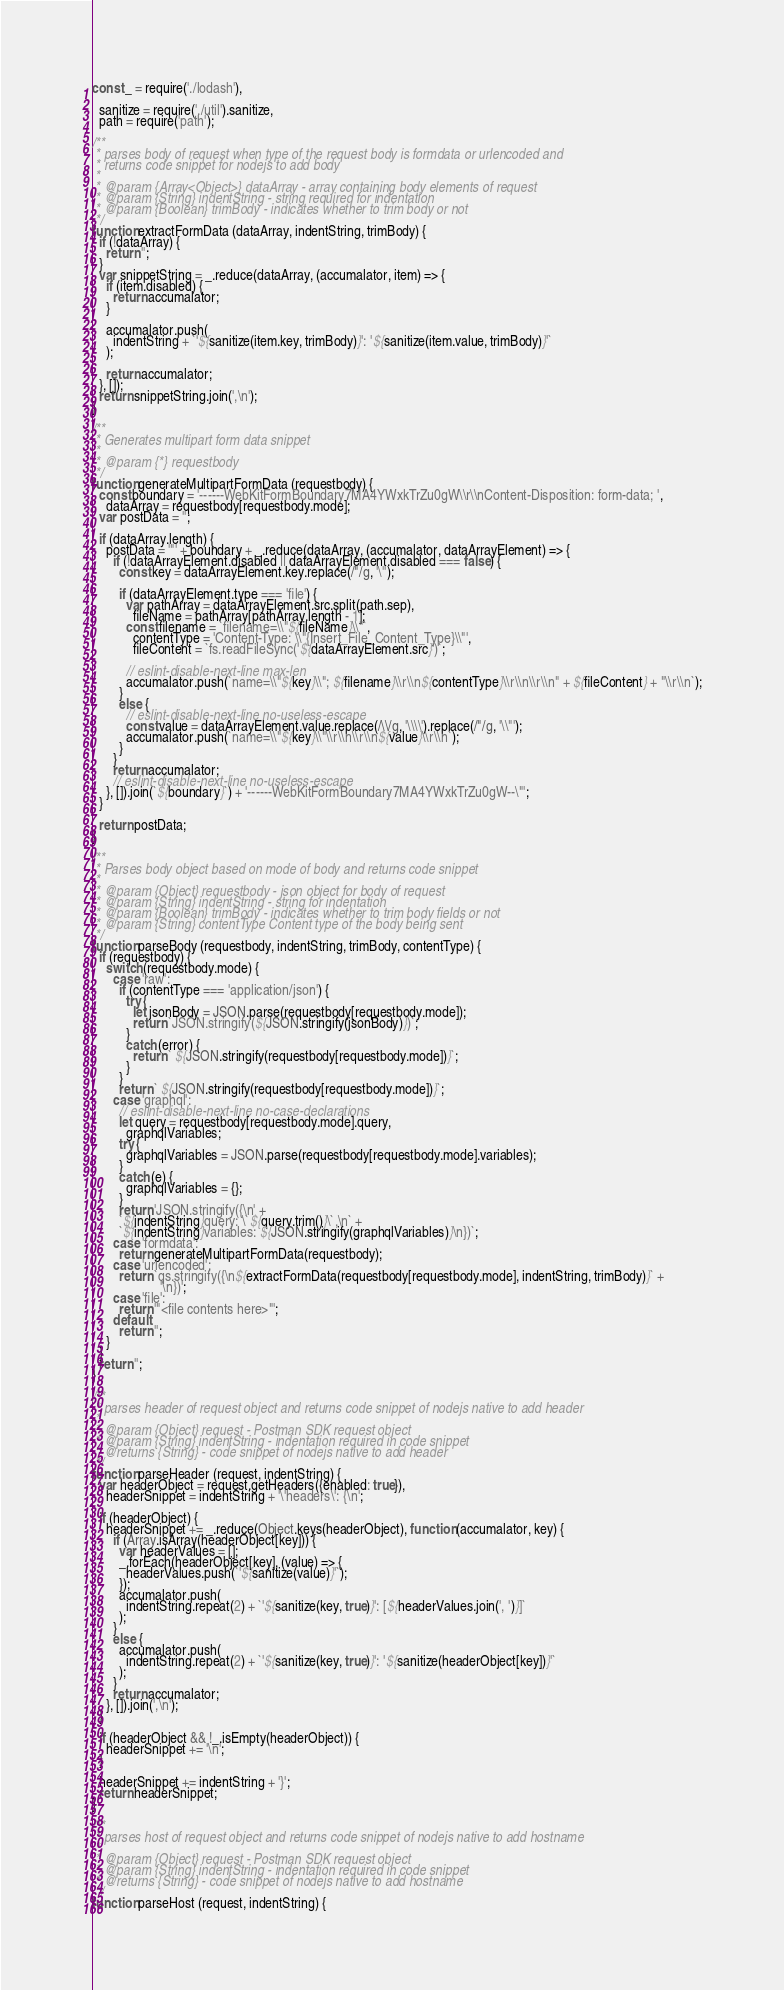<code> <loc_0><loc_0><loc_500><loc_500><_JavaScript_>const _ = require('./lodash'),

  sanitize = require('./util').sanitize,
  path = require('path');

/**
 * parses body of request when type of the request body is formdata or urlencoded and
 * returns code snippet for nodejs to add body
 *
 * @param {Array<Object>} dataArray - array containing body elements of request
 * @param {String} indentString - string required for indentation
 * @param {Boolean} trimBody - indicates whether to trim body or not
 */
function extractFormData (dataArray, indentString, trimBody) {
  if (!dataArray) {
    return '';
  }
  var snippetString = _.reduce(dataArray, (accumalator, item) => {
    if (item.disabled) {
      return accumalator;
    }

    accumalator.push(
      indentString + `'${sanitize(item.key, trimBody)}': '${sanitize(item.value, trimBody)}'`
    );

    return accumalator;
  }, []);
  return snippetString.join(',\n');
}

/**
 * Generates multipart form data snippet
 *
 * @param {*} requestbody
 */
function generateMultipartFormData (requestbody) {
  const boundary = '------WebKitFormBoundary7MA4YWxkTrZu0gW\\r\\nContent-Disposition: form-data; ',
    dataArray = requestbody[requestbody.mode];
  var postData = '';

  if (dataArray.length) {
    postData = '"' + boundary + _.reduce(dataArray, (accumalator, dataArrayElement) => {
      if (!dataArrayElement.disabled || dataArrayElement.disabled === false) {
        const key = dataArrayElement.key.replace(/"/g, '\'');

        if (dataArrayElement.type === 'file') {
          var pathArray = dataArrayElement.src.split(path.sep),
            fileName = pathArray[pathArray.length - 1];
          const filename = `filename=\\"${fileName}\\"`,
            contentType = 'Content-Type: \\"{Insert_File_Content_Type}\\"',
            fileContent = `fs.readFileSync('${dataArrayElement.src}')`;

          // eslint-disable-next-line max-len
          accumalator.push(`name=\\"${key}\\"; ${filename}\\r\\n${contentType}\\r\\n\\r\\n" + ${fileContent} + "\\r\\n`);
        }
        else {
          // eslint-disable-next-line no-useless-escape
          const value = dataArrayElement.value.replace(/\\/g, '\\\\').replace(/"/g, '\\"');
          accumalator.push(`name=\\"${key}\\"\\r\\n\\r\\n${value}\\r\\n`);
        }
      }
      return accumalator;
      // eslint-disable-next-line no-useless-escape
    }, []).join(`${boundary}`) + '------WebKitFormBoundary7MA4YWxkTrZu0gW--\"';
  }

  return postData;
}

/**
 * Parses body object based on mode of body and returns code snippet
 *
 * @param {Object} requestbody - json object for body of request
 * @param {String} indentString - string for indentation
 * @param {Boolean} trimBody - indicates whether to trim body fields or not
 * @param {String} contentType Content type of the body being sent
 */
function parseBody (requestbody, indentString, trimBody, contentType) {
  if (requestbody) {
    switch (requestbody.mode) {
      case 'raw':
        if (contentType === 'application/json') {
          try {
            let jsonBody = JSON.parse(requestbody[requestbody.mode]);
            return `JSON.stringify(${JSON.stringify(jsonBody)})`;
          }
          catch (error) {
            return ` ${JSON.stringify(requestbody[requestbody.mode])}`;
          }
        }
        return ` ${JSON.stringify(requestbody[requestbody.mode])}`;
      case 'graphql':
        // eslint-disable-next-line no-case-declarations
        let query = requestbody[requestbody.mode].query,
          graphqlVariables;
        try {
          graphqlVariables = JSON.parse(requestbody[requestbody.mode].variables);
        }
        catch (e) {
          graphqlVariables = {};
        }
        return 'JSON.stringify({\n' +
        `${indentString}query: \`${query.trim()}\`,\n` +
        `${indentString}variables: ${JSON.stringify(graphqlVariables)}\n})`;
      case 'formdata':
        return generateMultipartFormData(requestbody);
      case 'urlencoded':
        return `qs.stringify({\n${extractFormData(requestbody[requestbody.mode], indentString, trimBody)}` +
                    '\n})';
      case 'file':
        return '"<file contents here>"';
      default:
        return '';
    }
  }
  return '';
}

/**
 * parses header of request object and returns code snippet of nodejs native to add header
 *
 * @param {Object} request - Postman SDK request object
 * @param {String} indentString - indentation required in code snippet
 * @returns {String} - code snippet of nodejs native to add header
 */
function parseHeader (request, indentString) {
  var headerObject = request.getHeaders({enabled: true}),
    headerSnippet = indentString + '\'headers\': {\n';

  if (headerObject) {
    headerSnippet += _.reduce(Object.keys(headerObject), function (accumalator, key) {
      if (Array.isArray(headerObject[key])) {
        var headerValues = [];
        _.forEach(headerObject[key], (value) => {
          headerValues.push(`'${sanitize(value)}'`);
        });
        accumalator.push(
          indentString.repeat(2) + `'${sanitize(key, true)}': [${headerValues.join(', ')}]`
        );
      }
      else {
        accumalator.push(
          indentString.repeat(2) + `'${sanitize(key, true)}': '${sanitize(headerObject[key])}'`
        );
      }
      return accumalator;
    }, []).join(',\n');
  }

  if (headerObject && !_.isEmpty(headerObject)) {
    headerSnippet += '\n';
  }

  headerSnippet += indentString + '}';
  return headerSnippet;
}

/**
 * parses host of request object and returns code snippet of nodejs native to add hostname
 *
 * @param {Object} request - Postman SDK request object
 * @param {String} indentString - indentation required in code snippet
 * @returns {String} - code snippet of nodejs native to add hostname
 */
function parseHost (request, indentString) {</code> 